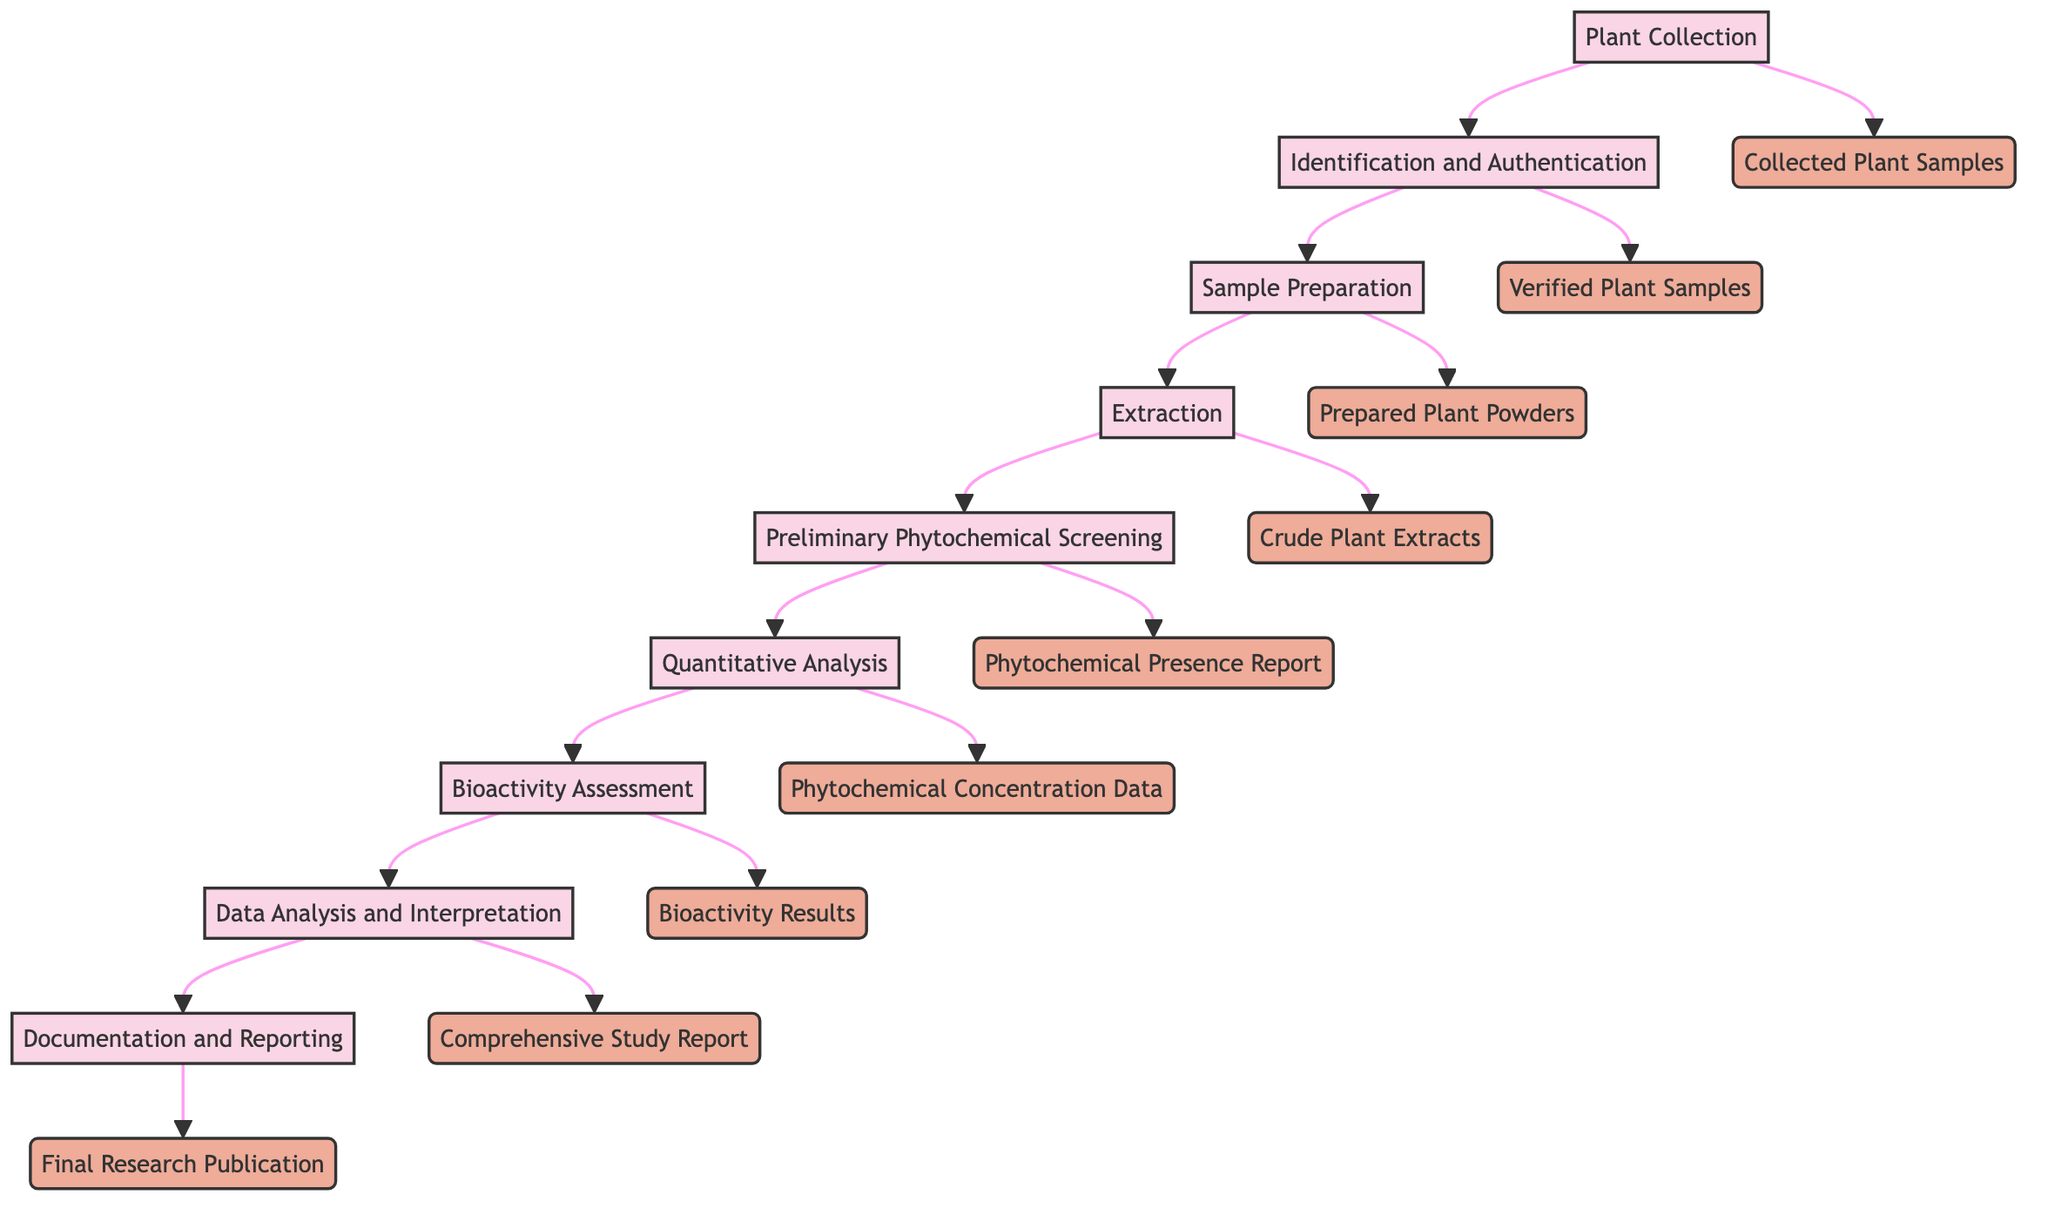What is the first step in the workflow? The first step in the workflow is shown at the top of the diagram leading to the next node, which indicates that it is "Plant Collection."
Answer: Plant Collection How many total steps are there in the workflow? By counting each distinct step listed in the diagram, there are nine steps outlined in the workflow.
Answer: 9 What is the output of the "Extraction" step? The output from the "Extraction" step is connected to the next step in the flow, which identifies it as "Crude Plant Extracts."
Answer: Crude Plant Extracts What step comes after "Bioactivity Assessment"? The flow shows that the next step following "Bioactivity Assessment" is "Data Analysis and Interpretation," connecting these two nodes sequentially.
Answer: Data Analysis and Interpretation Which step involves the use of solvents? The "Extraction" step is specifically where solvents like ethanol, methanol, or water are used, according to the description.
Answer: Extraction What output follows "Preliminary Phytochemical Screening"? After "Preliminary Phytochemical Screening," the output that follows is "Phytochemical Concentration Data," indicating that this data comes from the subsequent quantitative analysis step.
Answer: Phytochemical Concentration Data Which two steps lead to the output "Final Research Publication"? The steps "Data Analysis and Interpretation" and "Documentation and Reporting" lead to the final output, which is shown as "Final Research Publication" at the end of the workflow.
Answer: Data Analysis and Interpretation, Documentation and Reporting What is assessed in the "Bioactivity Assessment" step? In the "Bioactivity Assessment" step, the biological activity of the extracts is evaluated, as indicated by the description connected to this node.
Answer: Biological activity What type of analysis is conducted after "Quantitative Analysis"? After "Quantitative Analysis," the workflow progresses to "Bioactivity Assessment," indicating that this is the type of analysis conducted next.
Answer: Bioactivity Assessment 